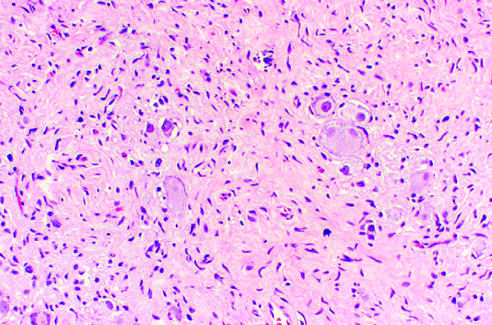s a liver characterized by clusters of large ganglion cells with vesicular nuclei and abundant eosinophilic cytoplasm arrow?
Answer the question using a single word or phrase. No 